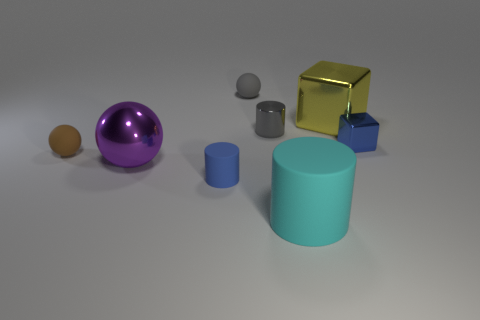There is a tiny gray object that is the same shape as the big cyan rubber object; what material is it?
Offer a terse response. Metal. Is there anything else that has the same material as the tiny brown sphere?
Offer a terse response. Yes. How many gray things are metal things or big cubes?
Provide a succinct answer. 1. There is a sphere on the left side of the big purple metal sphere; what is it made of?
Make the answer very short. Rubber. Are there more small brown rubber cylinders than tiny blue cubes?
Provide a succinct answer. No. Does the big shiny thing that is in front of the tiny gray metal cylinder have the same shape as the brown object?
Your response must be concise. Yes. What number of cylinders are both right of the gray shiny object and on the left side of the metal cylinder?
Provide a short and direct response. 0. How many gray shiny objects are the same shape as the large matte object?
Provide a succinct answer. 1. The tiny matte sphere that is behind the yellow metallic block that is on the right side of the brown sphere is what color?
Offer a terse response. Gray. There is a tiny brown object; is it the same shape as the gray thing behind the tiny gray cylinder?
Provide a short and direct response. Yes. 